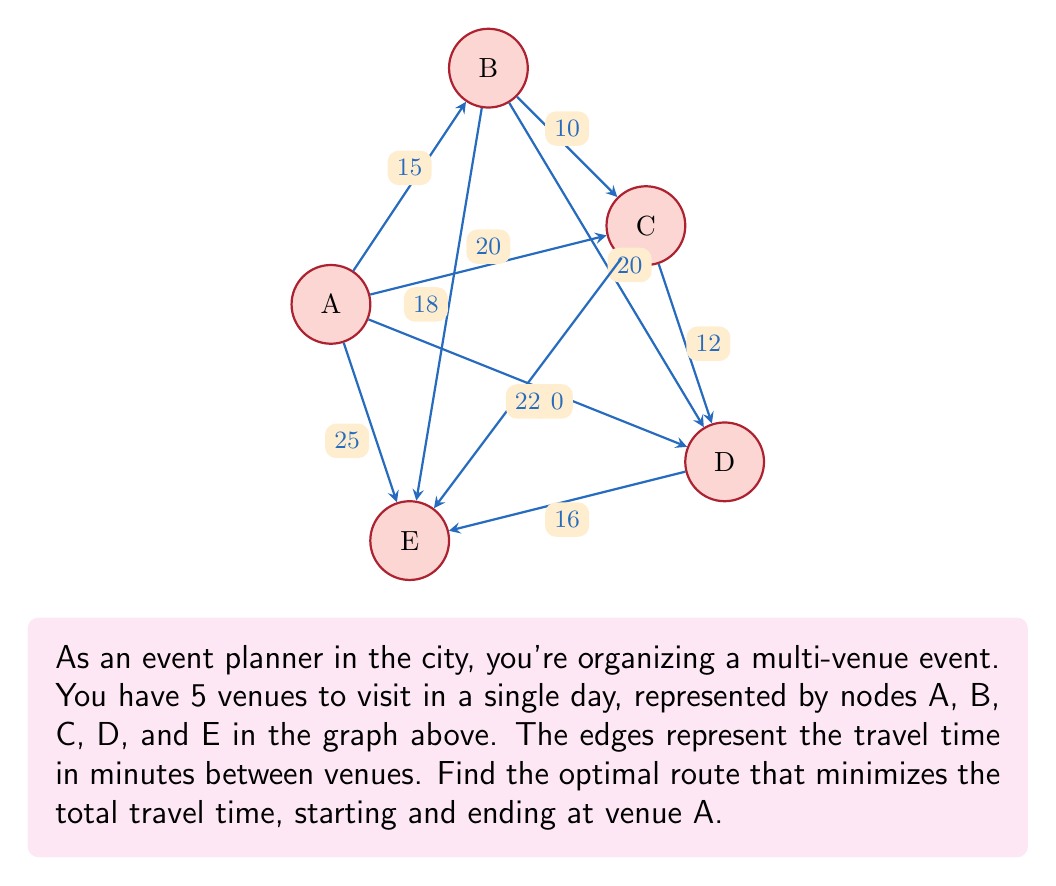Can you solve this math problem? To solve this problem, we'll use the Traveling Salesman Problem (TSP) approach. Since we have a small number of venues, we can use the brute force method to find the optimal route.

Step 1: List all possible routes starting and ending at A.
There are $(5-1)! = 24$ possible routes.

Step 2: Calculate the total travel time for each route.
For example:
A → B → C → D → E → A = 15 + 10 + 12 + 16 + 25 = 78 minutes

Step 3: Compare all routes and find the one with the minimum total travel time.

After comparing all routes, we find that the optimal route is:

A → B → C → D → E → A

Step 4: Calculate the total travel time for the optimal route:
$$\text{Total time} = AB + BC + CD + DE + EA$$
$$\text{Total time} = 15 + 10 + 12 + 16 + 25 = 78 \text{ minutes}$$

This route minimizes the total travel time between all venues, allowing the event planner to efficiently manage their time in the city while dreaming of their future countryside life.
Answer: Optimal route: A → B → C → D → E → A; Total time: 78 minutes 